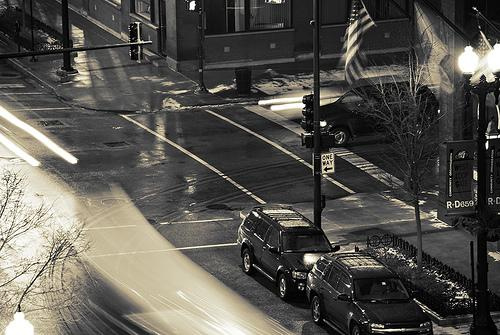What flag can be seen here?

Choices:
A) france
B) china
C) united states
D) germany united states 